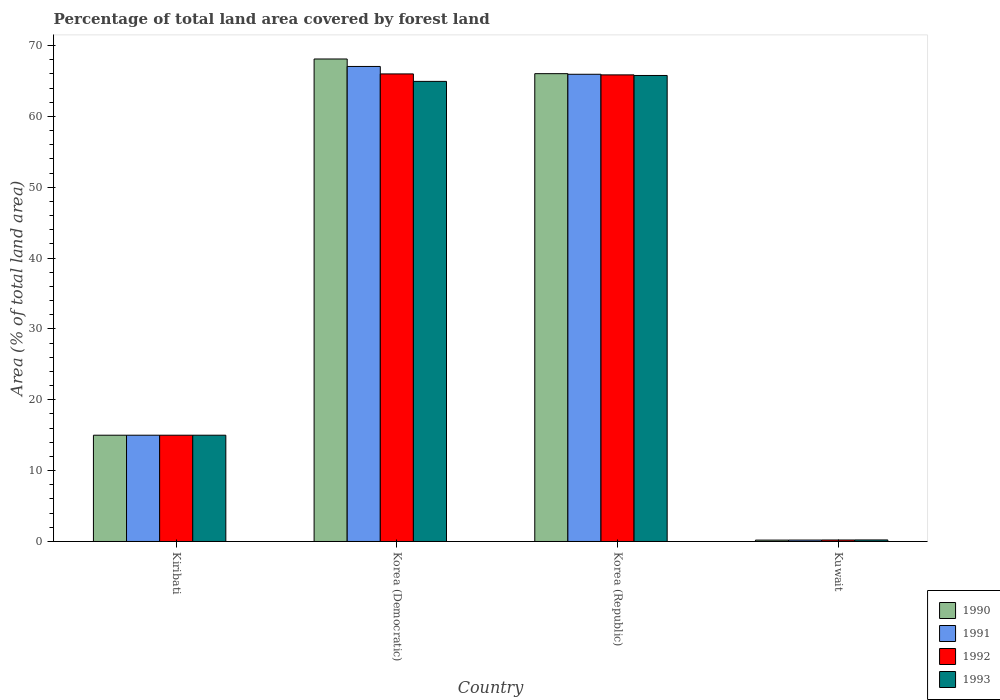How many different coloured bars are there?
Provide a succinct answer. 4. Are the number of bars on each tick of the X-axis equal?
Your answer should be very brief. Yes. How many bars are there on the 2nd tick from the right?
Keep it short and to the point. 4. What is the label of the 4th group of bars from the left?
Offer a very short reply. Kuwait. What is the percentage of forest land in 1990 in Korea (Democratic)?
Provide a succinct answer. 68.11. Across all countries, what is the maximum percentage of forest land in 1992?
Ensure brevity in your answer.  66. Across all countries, what is the minimum percentage of forest land in 1990?
Ensure brevity in your answer.  0.19. In which country was the percentage of forest land in 1992 minimum?
Make the answer very short. Kuwait. What is the total percentage of forest land in 1993 in the graph?
Provide a succinct answer. 145.95. What is the difference between the percentage of forest land in 1991 in Korea (Democratic) and that in Korea (Republic)?
Ensure brevity in your answer.  1.1. What is the difference between the percentage of forest land in 1992 in Kuwait and the percentage of forest land in 1991 in Kiribati?
Provide a succinct answer. -14.79. What is the average percentage of forest land in 1990 per country?
Keep it short and to the point. 37.34. What is the difference between the percentage of forest land of/in 1990 and percentage of forest land of/in 1993 in Korea (Democratic)?
Your response must be concise. 3.16. In how many countries, is the percentage of forest land in 1992 greater than 6 %?
Offer a very short reply. 3. What is the ratio of the percentage of forest land in 1991 in Kiribati to that in Korea (Democratic)?
Offer a terse response. 0.22. Is the percentage of forest land in 1990 in Kiribati less than that in Kuwait?
Give a very brief answer. No. Is the difference between the percentage of forest land in 1990 in Korea (Democratic) and Kuwait greater than the difference between the percentage of forest land in 1993 in Korea (Democratic) and Kuwait?
Give a very brief answer. Yes. What is the difference between the highest and the second highest percentage of forest land in 1990?
Keep it short and to the point. -2.07. What is the difference between the highest and the lowest percentage of forest land in 1991?
Provide a succinct answer. 66.85. Is the sum of the percentage of forest land in 1991 in Korea (Democratic) and Korea (Republic) greater than the maximum percentage of forest land in 1990 across all countries?
Your response must be concise. Yes. What does the 1st bar from the left in Kuwait represents?
Offer a very short reply. 1990. What does the 4th bar from the right in Kiribati represents?
Your response must be concise. 1990. Is it the case that in every country, the sum of the percentage of forest land in 1992 and percentage of forest land in 1991 is greater than the percentage of forest land in 1993?
Your answer should be compact. Yes. How many bars are there?
Your answer should be compact. 16. How many countries are there in the graph?
Your answer should be very brief. 4. What is the difference between two consecutive major ticks on the Y-axis?
Offer a terse response. 10. Are the values on the major ticks of Y-axis written in scientific E-notation?
Ensure brevity in your answer.  No. Where does the legend appear in the graph?
Offer a terse response. Bottom right. How many legend labels are there?
Offer a very short reply. 4. How are the legend labels stacked?
Your answer should be very brief. Vertical. What is the title of the graph?
Give a very brief answer. Percentage of total land area covered by forest land. Does "1983" appear as one of the legend labels in the graph?
Make the answer very short. No. What is the label or title of the X-axis?
Offer a very short reply. Country. What is the label or title of the Y-axis?
Keep it short and to the point. Area (% of total land area). What is the Area (% of total land area) in 1990 in Kiribati?
Your answer should be very brief. 15. What is the Area (% of total land area) in 1991 in Kiribati?
Provide a succinct answer. 15. What is the Area (% of total land area) of 1990 in Korea (Democratic)?
Provide a succinct answer. 68.11. What is the Area (% of total land area) in 1991 in Korea (Democratic)?
Your answer should be compact. 67.06. What is the Area (% of total land area) of 1992 in Korea (Democratic)?
Make the answer very short. 66. What is the Area (% of total land area) of 1993 in Korea (Democratic)?
Ensure brevity in your answer.  64.95. What is the Area (% of total land area) of 1990 in Korea (Republic)?
Make the answer very short. 66.04. What is the Area (% of total land area) in 1991 in Korea (Republic)?
Your answer should be very brief. 65.95. What is the Area (% of total land area) in 1992 in Korea (Republic)?
Offer a very short reply. 65.87. What is the Area (% of total land area) in 1993 in Korea (Republic)?
Provide a succinct answer. 65.78. What is the Area (% of total land area) of 1990 in Kuwait?
Offer a very short reply. 0.19. What is the Area (% of total land area) in 1991 in Kuwait?
Keep it short and to the point. 0.2. What is the Area (% of total land area) in 1992 in Kuwait?
Your answer should be very brief. 0.21. What is the Area (% of total land area) of 1993 in Kuwait?
Offer a very short reply. 0.22. Across all countries, what is the maximum Area (% of total land area) in 1990?
Provide a succinct answer. 68.11. Across all countries, what is the maximum Area (% of total land area) of 1991?
Your answer should be compact. 67.06. Across all countries, what is the maximum Area (% of total land area) in 1992?
Offer a very short reply. 66. Across all countries, what is the maximum Area (% of total land area) in 1993?
Give a very brief answer. 65.78. Across all countries, what is the minimum Area (% of total land area) of 1990?
Offer a very short reply. 0.19. Across all countries, what is the minimum Area (% of total land area) in 1991?
Your answer should be very brief. 0.2. Across all countries, what is the minimum Area (% of total land area) in 1992?
Make the answer very short. 0.21. Across all countries, what is the minimum Area (% of total land area) in 1993?
Keep it short and to the point. 0.22. What is the total Area (% of total land area) in 1990 in the graph?
Ensure brevity in your answer.  149.34. What is the total Area (% of total land area) of 1991 in the graph?
Give a very brief answer. 148.21. What is the total Area (% of total land area) of 1992 in the graph?
Ensure brevity in your answer.  147.08. What is the total Area (% of total land area) in 1993 in the graph?
Your answer should be very brief. 145.95. What is the difference between the Area (% of total land area) in 1990 in Kiribati and that in Korea (Democratic)?
Your response must be concise. -53.11. What is the difference between the Area (% of total land area) in 1991 in Kiribati and that in Korea (Democratic)?
Keep it short and to the point. -52.06. What is the difference between the Area (% of total land area) of 1992 in Kiribati and that in Korea (Democratic)?
Your answer should be very brief. -51. What is the difference between the Area (% of total land area) in 1993 in Kiribati and that in Korea (Democratic)?
Keep it short and to the point. -49.95. What is the difference between the Area (% of total land area) in 1990 in Kiribati and that in Korea (Republic)?
Give a very brief answer. -51.04. What is the difference between the Area (% of total land area) in 1991 in Kiribati and that in Korea (Republic)?
Keep it short and to the point. -50.95. What is the difference between the Area (% of total land area) in 1992 in Kiribati and that in Korea (Republic)?
Your answer should be compact. -50.87. What is the difference between the Area (% of total land area) in 1993 in Kiribati and that in Korea (Republic)?
Keep it short and to the point. -50.78. What is the difference between the Area (% of total land area) of 1990 in Kiribati and that in Kuwait?
Offer a terse response. 14.81. What is the difference between the Area (% of total land area) in 1991 in Kiribati and that in Kuwait?
Your answer should be very brief. 14.8. What is the difference between the Area (% of total land area) in 1992 in Kiribati and that in Kuwait?
Provide a short and direct response. 14.79. What is the difference between the Area (% of total land area) of 1993 in Kiribati and that in Kuwait?
Offer a very short reply. 14.78. What is the difference between the Area (% of total land area) in 1990 in Korea (Democratic) and that in Korea (Republic)?
Your answer should be compact. 2.07. What is the difference between the Area (% of total land area) of 1991 in Korea (Democratic) and that in Korea (Republic)?
Offer a very short reply. 1.1. What is the difference between the Area (% of total land area) in 1992 in Korea (Democratic) and that in Korea (Republic)?
Offer a very short reply. 0.14. What is the difference between the Area (% of total land area) in 1993 in Korea (Democratic) and that in Korea (Republic)?
Your answer should be compact. -0.83. What is the difference between the Area (% of total land area) of 1990 in Korea (Democratic) and that in Kuwait?
Offer a terse response. 67.92. What is the difference between the Area (% of total land area) in 1991 in Korea (Democratic) and that in Kuwait?
Offer a terse response. 66.85. What is the difference between the Area (% of total land area) of 1992 in Korea (Democratic) and that in Kuwait?
Your answer should be compact. 65.79. What is the difference between the Area (% of total land area) of 1993 in Korea (Democratic) and that in Kuwait?
Provide a short and direct response. 64.73. What is the difference between the Area (% of total land area) of 1990 in Korea (Republic) and that in Kuwait?
Your answer should be compact. 65.84. What is the difference between the Area (% of total land area) in 1991 in Korea (Republic) and that in Kuwait?
Your answer should be compact. 65.75. What is the difference between the Area (% of total land area) in 1992 in Korea (Republic) and that in Kuwait?
Offer a terse response. 65.66. What is the difference between the Area (% of total land area) in 1993 in Korea (Republic) and that in Kuwait?
Your answer should be very brief. 65.57. What is the difference between the Area (% of total land area) of 1990 in Kiribati and the Area (% of total land area) of 1991 in Korea (Democratic)?
Give a very brief answer. -52.06. What is the difference between the Area (% of total land area) in 1990 in Kiribati and the Area (% of total land area) in 1992 in Korea (Democratic)?
Ensure brevity in your answer.  -51. What is the difference between the Area (% of total land area) of 1990 in Kiribati and the Area (% of total land area) of 1993 in Korea (Democratic)?
Make the answer very short. -49.95. What is the difference between the Area (% of total land area) in 1991 in Kiribati and the Area (% of total land area) in 1992 in Korea (Democratic)?
Keep it short and to the point. -51. What is the difference between the Area (% of total land area) in 1991 in Kiribati and the Area (% of total land area) in 1993 in Korea (Democratic)?
Provide a succinct answer. -49.95. What is the difference between the Area (% of total land area) of 1992 in Kiribati and the Area (% of total land area) of 1993 in Korea (Democratic)?
Make the answer very short. -49.95. What is the difference between the Area (% of total land area) of 1990 in Kiribati and the Area (% of total land area) of 1991 in Korea (Republic)?
Ensure brevity in your answer.  -50.95. What is the difference between the Area (% of total land area) in 1990 in Kiribati and the Area (% of total land area) in 1992 in Korea (Republic)?
Your response must be concise. -50.87. What is the difference between the Area (% of total land area) of 1990 in Kiribati and the Area (% of total land area) of 1993 in Korea (Republic)?
Your answer should be very brief. -50.78. What is the difference between the Area (% of total land area) of 1991 in Kiribati and the Area (% of total land area) of 1992 in Korea (Republic)?
Give a very brief answer. -50.87. What is the difference between the Area (% of total land area) of 1991 in Kiribati and the Area (% of total land area) of 1993 in Korea (Republic)?
Offer a very short reply. -50.78. What is the difference between the Area (% of total land area) in 1992 in Kiribati and the Area (% of total land area) in 1993 in Korea (Republic)?
Give a very brief answer. -50.78. What is the difference between the Area (% of total land area) of 1990 in Kiribati and the Area (% of total land area) of 1991 in Kuwait?
Give a very brief answer. 14.8. What is the difference between the Area (% of total land area) of 1990 in Kiribati and the Area (% of total land area) of 1992 in Kuwait?
Offer a terse response. 14.79. What is the difference between the Area (% of total land area) in 1990 in Kiribati and the Area (% of total land area) in 1993 in Kuwait?
Give a very brief answer. 14.78. What is the difference between the Area (% of total land area) of 1991 in Kiribati and the Area (% of total land area) of 1992 in Kuwait?
Offer a very short reply. 14.79. What is the difference between the Area (% of total land area) in 1991 in Kiribati and the Area (% of total land area) in 1993 in Kuwait?
Your answer should be very brief. 14.78. What is the difference between the Area (% of total land area) of 1992 in Kiribati and the Area (% of total land area) of 1993 in Kuwait?
Your answer should be very brief. 14.78. What is the difference between the Area (% of total land area) of 1990 in Korea (Democratic) and the Area (% of total land area) of 1991 in Korea (Republic)?
Ensure brevity in your answer.  2.16. What is the difference between the Area (% of total land area) in 1990 in Korea (Democratic) and the Area (% of total land area) in 1992 in Korea (Republic)?
Give a very brief answer. 2.24. What is the difference between the Area (% of total land area) in 1990 in Korea (Democratic) and the Area (% of total land area) in 1993 in Korea (Republic)?
Ensure brevity in your answer.  2.33. What is the difference between the Area (% of total land area) of 1991 in Korea (Democratic) and the Area (% of total land area) of 1992 in Korea (Republic)?
Your response must be concise. 1.19. What is the difference between the Area (% of total land area) of 1991 in Korea (Democratic) and the Area (% of total land area) of 1993 in Korea (Republic)?
Your answer should be very brief. 1.27. What is the difference between the Area (% of total land area) of 1992 in Korea (Democratic) and the Area (% of total land area) of 1993 in Korea (Republic)?
Your response must be concise. 0.22. What is the difference between the Area (% of total land area) in 1990 in Korea (Democratic) and the Area (% of total land area) in 1991 in Kuwait?
Offer a terse response. 67.91. What is the difference between the Area (% of total land area) in 1990 in Korea (Democratic) and the Area (% of total land area) in 1992 in Kuwait?
Offer a terse response. 67.9. What is the difference between the Area (% of total land area) of 1990 in Korea (Democratic) and the Area (% of total land area) of 1993 in Kuwait?
Your answer should be very brief. 67.89. What is the difference between the Area (% of total land area) of 1991 in Korea (Democratic) and the Area (% of total land area) of 1992 in Kuwait?
Offer a very short reply. 66.85. What is the difference between the Area (% of total land area) in 1991 in Korea (Democratic) and the Area (% of total land area) in 1993 in Kuwait?
Offer a very short reply. 66.84. What is the difference between the Area (% of total land area) in 1992 in Korea (Democratic) and the Area (% of total land area) in 1993 in Kuwait?
Ensure brevity in your answer.  65.79. What is the difference between the Area (% of total land area) of 1990 in Korea (Republic) and the Area (% of total land area) of 1991 in Kuwait?
Your answer should be very brief. 65.84. What is the difference between the Area (% of total land area) of 1990 in Korea (Republic) and the Area (% of total land area) of 1992 in Kuwait?
Offer a very short reply. 65.83. What is the difference between the Area (% of total land area) in 1990 in Korea (Republic) and the Area (% of total land area) in 1993 in Kuwait?
Ensure brevity in your answer.  65.82. What is the difference between the Area (% of total land area) of 1991 in Korea (Republic) and the Area (% of total land area) of 1992 in Kuwait?
Give a very brief answer. 65.74. What is the difference between the Area (% of total land area) of 1991 in Korea (Republic) and the Area (% of total land area) of 1993 in Kuwait?
Offer a terse response. 65.74. What is the difference between the Area (% of total land area) of 1992 in Korea (Republic) and the Area (% of total land area) of 1993 in Kuwait?
Ensure brevity in your answer.  65.65. What is the average Area (% of total land area) of 1990 per country?
Offer a very short reply. 37.34. What is the average Area (% of total land area) of 1991 per country?
Your answer should be very brief. 37.05. What is the average Area (% of total land area) of 1992 per country?
Keep it short and to the point. 36.77. What is the average Area (% of total land area) in 1993 per country?
Keep it short and to the point. 36.49. What is the difference between the Area (% of total land area) of 1990 and Area (% of total land area) of 1991 in Kiribati?
Offer a terse response. 0. What is the difference between the Area (% of total land area) in 1990 and Area (% of total land area) in 1992 in Kiribati?
Offer a very short reply. 0. What is the difference between the Area (% of total land area) in 1991 and Area (% of total land area) in 1992 in Kiribati?
Keep it short and to the point. 0. What is the difference between the Area (% of total land area) in 1990 and Area (% of total land area) in 1991 in Korea (Democratic)?
Your response must be concise. 1.05. What is the difference between the Area (% of total land area) of 1990 and Area (% of total land area) of 1992 in Korea (Democratic)?
Provide a succinct answer. 2.11. What is the difference between the Area (% of total land area) in 1990 and Area (% of total land area) in 1993 in Korea (Democratic)?
Your response must be concise. 3.16. What is the difference between the Area (% of total land area) in 1991 and Area (% of total land area) in 1992 in Korea (Democratic)?
Ensure brevity in your answer.  1.05. What is the difference between the Area (% of total land area) of 1991 and Area (% of total land area) of 1993 in Korea (Democratic)?
Keep it short and to the point. 2.11. What is the difference between the Area (% of total land area) of 1992 and Area (% of total land area) of 1993 in Korea (Democratic)?
Give a very brief answer. 1.05. What is the difference between the Area (% of total land area) of 1990 and Area (% of total land area) of 1991 in Korea (Republic)?
Offer a terse response. 0.09. What is the difference between the Area (% of total land area) in 1990 and Area (% of total land area) in 1992 in Korea (Republic)?
Your response must be concise. 0.17. What is the difference between the Area (% of total land area) of 1990 and Area (% of total land area) of 1993 in Korea (Republic)?
Keep it short and to the point. 0.26. What is the difference between the Area (% of total land area) of 1991 and Area (% of total land area) of 1992 in Korea (Republic)?
Provide a succinct answer. 0.09. What is the difference between the Area (% of total land area) in 1991 and Area (% of total land area) in 1993 in Korea (Republic)?
Your answer should be very brief. 0.17. What is the difference between the Area (% of total land area) in 1992 and Area (% of total land area) in 1993 in Korea (Republic)?
Ensure brevity in your answer.  0.09. What is the difference between the Area (% of total land area) of 1990 and Area (% of total land area) of 1991 in Kuwait?
Provide a short and direct response. -0.01. What is the difference between the Area (% of total land area) in 1990 and Area (% of total land area) in 1992 in Kuwait?
Keep it short and to the point. -0.02. What is the difference between the Area (% of total land area) of 1990 and Area (% of total land area) of 1993 in Kuwait?
Offer a terse response. -0.02. What is the difference between the Area (% of total land area) in 1991 and Area (% of total land area) in 1992 in Kuwait?
Your response must be concise. -0.01. What is the difference between the Area (% of total land area) of 1991 and Area (% of total land area) of 1993 in Kuwait?
Keep it short and to the point. -0.02. What is the difference between the Area (% of total land area) in 1992 and Area (% of total land area) in 1993 in Kuwait?
Ensure brevity in your answer.  -0.01. What is the ratio of the Area (% of total land area) in 1990 in Kiribati to that in Korea (Democratic)?
Offer a very short reply. 0.22. What is the ratio of the Area (% of total land area) in 1991 in Kiribati to that in Korea (Democratic)?
Offer a terse response. 0.22. What is the ratio of the Area (% of total land area) of 1992 in Kiribati to that in Korea (Democratic)?
Offer a very short reply. 0.23. What is the ratio of the Area (% of total land area) in 1993 in Kiribati to that in Korea (Democratic)?
Offer a terse response. 0.23. What is the ratio of the Area (% of total land area) of 1990 in Kiribati to that in Korea (Republic)?
Provide a short and direct response. 0.23. What is the ratio of the Area (% of total land area) in 1991 in Kiribati to that in Korea (Republic)?
Ensure brevity in your answer.  0.23. What is the ratio of the Area (% of total land area) in 1992 in Kiribati to that in Korea (Republic)?
Make the answer very short. 0.23. What is the ratio of the Area (% of total land area) of 1993 in Kiribati to that in Korea (Republic)?
Provide a short and direct response. 0.23. What is the ratio of the Area (% of total land area) in 1990 in Kiribati to that in Kuwait?
Make the answer very short. 77.48. What is the ratio of the Area (% of total land area) of 1991 in Kiribati to that in Kuwait?
Offer a very short reply. 74.46. What is the ratio of the Area (% of total land area) in 1992 in Kiribati to that in Kuwait?
Provide a short and direct response. 71.66. What is the ratio of the Area (% of total land area) in 1993 in Kiribati to that in Kuwait?
Ensure brevity in your answer.  69.07. What is the ratio of the Area (% of total land area) in 1990 in Korea (Democratic) to that in Korea (Republic)?
Your answer should be compact. 1.03. What is the ratio of the Area (% of total land area) of 1991 in Korea (Democratic) to that in Korea (Republic)?
Your response must be concise. 1.02. What is the ratio of the Area (% of total land area) in 1993 in Korea (Democratic) to that in Korea (Republic)?
Your answer should be very brief. 0.99. What is the ratio of the Area (% of total land area) of 1990 in Korea (Democratic) to that in Kuwait?
Provide a short and direct response. 351.8. What is the ratio of the Area (% of total land area) of 1991 in Korea (Democratic) to that in Kuwait?
Offer a very short reply. 332.85. What is the ratio of the Area (% of total land area) in 1992 in Korea (Democratic) to that in Kuwait?
Give a very brief answer. 315.33. What is the ratio of the Area (% of total land area) of 1993 in Korea (Democratic) to that in Kuwait?
Your response must be concise. 299.07. What is the ratio of the Area (% of total land area) in 1990 in Korea (Republic) to that in Kuwait?
Keep it short and to the point. 341.1. What is the ratio of the Area (% of total land area) of 1991 in Korea (Republic) to that in Kuwait?
Make the answer very short. 327.38. What is the ratio of the Area (% of total land area) of 1992 in Korea (Republic) to that in Kuwait?
Provide a short and direct response. 314.68. What is the ratio of the Area (% of total land area) of 1993 in Korea (Republic) to that in Kuwait?
Your response must be concise. 302.91. What is the difference between the highest and the second highest Area (% of total land area) of 1990?
Offer a very short reply. 2.07. What is the difference between the highest and the second highest Area (% of total land area) in 1991?
Provide a short and direct response. 1.1. What is the difference between the highest and the second highest Area (% of total land area) of 1992?
Your answer should be compact. 0.14. What is the difference between the highest and the second highest Area (% of total land area) of 1993?
Give a very brief answer. 0.83. What is the difference between the highest and the lowest Area (% of total land area) in 1990?
Your answer should be very brief. 67.92. What is the difference between the highest and the lowest Area (% of total land area) in 1991?
Offer a terse response. 66.85. What is the difference between the highest and the lowest Area (% of total land area) in 1992?
Make the answer very short. 65.79. What is the difference between the highest and the lowest Area (% of total land area) in 1993?
Your answer should be very brief. 65.57. 